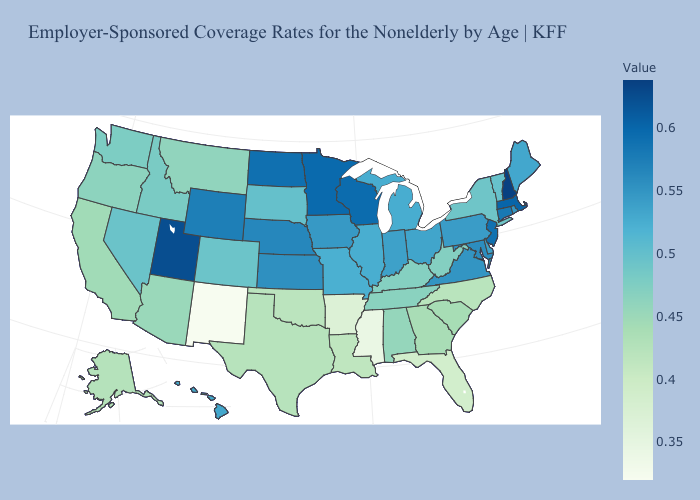Does New Mexico have the lowest value in the USA?
Be succinct. Yes. Does New Mexico have the lowest value in the USA?
Answer briefly. Yes. Does Maine have a higher value than Florida?
Answer briefly. Yes. Does New Mexico have the lowest value in the USA?
Concise answer only. Yes. Does Tennessee have a lower value than Maryland?
Short answer required. Yes. Does New Mexico have the lowest value in the USA?
Give a very brief answer. Yes. 